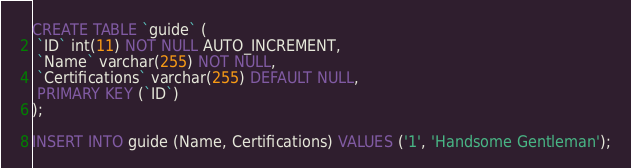Convert code to text. <code><loc_0><loc_0><loc_500><loc_500><_SQL_>CREATE TABLE `guide` (
 `ID` int(11) NOT NULL AUTO_INCREMENT,
 `Name` varchar(255) NOT NULL,
 `Certifications` varchar(255) DEFAULT NULL,
 PRIMARY KEY (`ID`)
);

INSERT INTO guide (Name, Certifications) VALUES ('1', 'Handsome Gentleman');</code> 